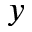<formula> <loc_0><loc_0><loc_500><loc_500>y</formula> 